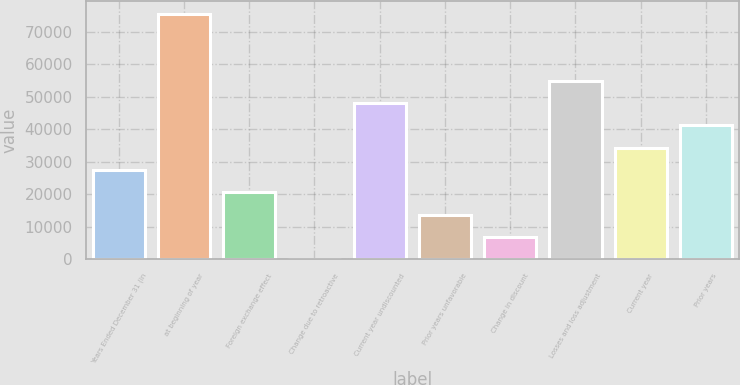Convert chart. <chart><loc_0><loc_0><loc_500><loc_500><bar_chart><fcel>Years Ended December 31 (in<fcel>at beginning of year<fcel>Foreign exchange effect<fcel>Change due to retroactive<fcel>Current year undiscounted<fcel>Prior years unfavorable<fcel>Change in discount<fcel>Losses and loss adjustment<fcel>Current year<fcel>Prior years<nl><fcel>27526<fcel>75658<fcel>20650<fcel>22<fcel>48154<fcel>13774<fcel>6898<fcel>55030<fcel>34402<fcel>41278<nl></chart> 